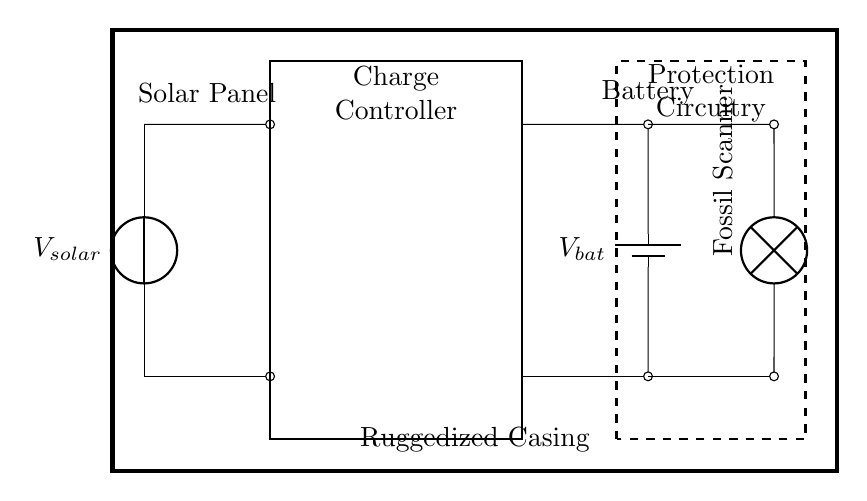What is the power source for this charging system? The power source in this circuit is the solar panel, which is depicted at the left side of the diagram and is labeled as "Vsolar."
Answer: Solar panel What type of battery is used in this circuit? The battery component in the diagram is labeled as "Vbat," which suggests it is a specific type of rechargeable battery, likely designed for this ruggedized application.
Answer: Battery How many major components are present in this charging circuit? The major components in the circuit include the solar panel, charge controller, battery, fossil scanner, and protection circuitry. By counting these elements, we find that there are five in total.
Answer: Five What is the purpose of the charge controller in this circuit? The charge controller regulates the voltage and current coming from the solar panel to ensure that the battery is charged properly without being overcharged, maintaining safe operation.
Answer: Regulation Where is the protection circuitry located in the charging system? The protection circuitry is shown as a dashed rectangular box in the middle-right area of the circuit diagram, specifically labeled as "Protection Circuitry."
Answer: Middle-right area How does the fossil scanner connect to the battery? The fossil scanner connects to the battery through a short line that extends from the battery's positive and negative terminals, indicating a direct electrical connection for power supply.
Answer: Directly connected What does the ruggedized casing indicate about the circuit? The ruggedized casing signifies that the circuit is designed to be durable and capable of withstanding harsh environments, making it suitable for use in outdoor locations like fossil excavation sites.
Answer: Durability 